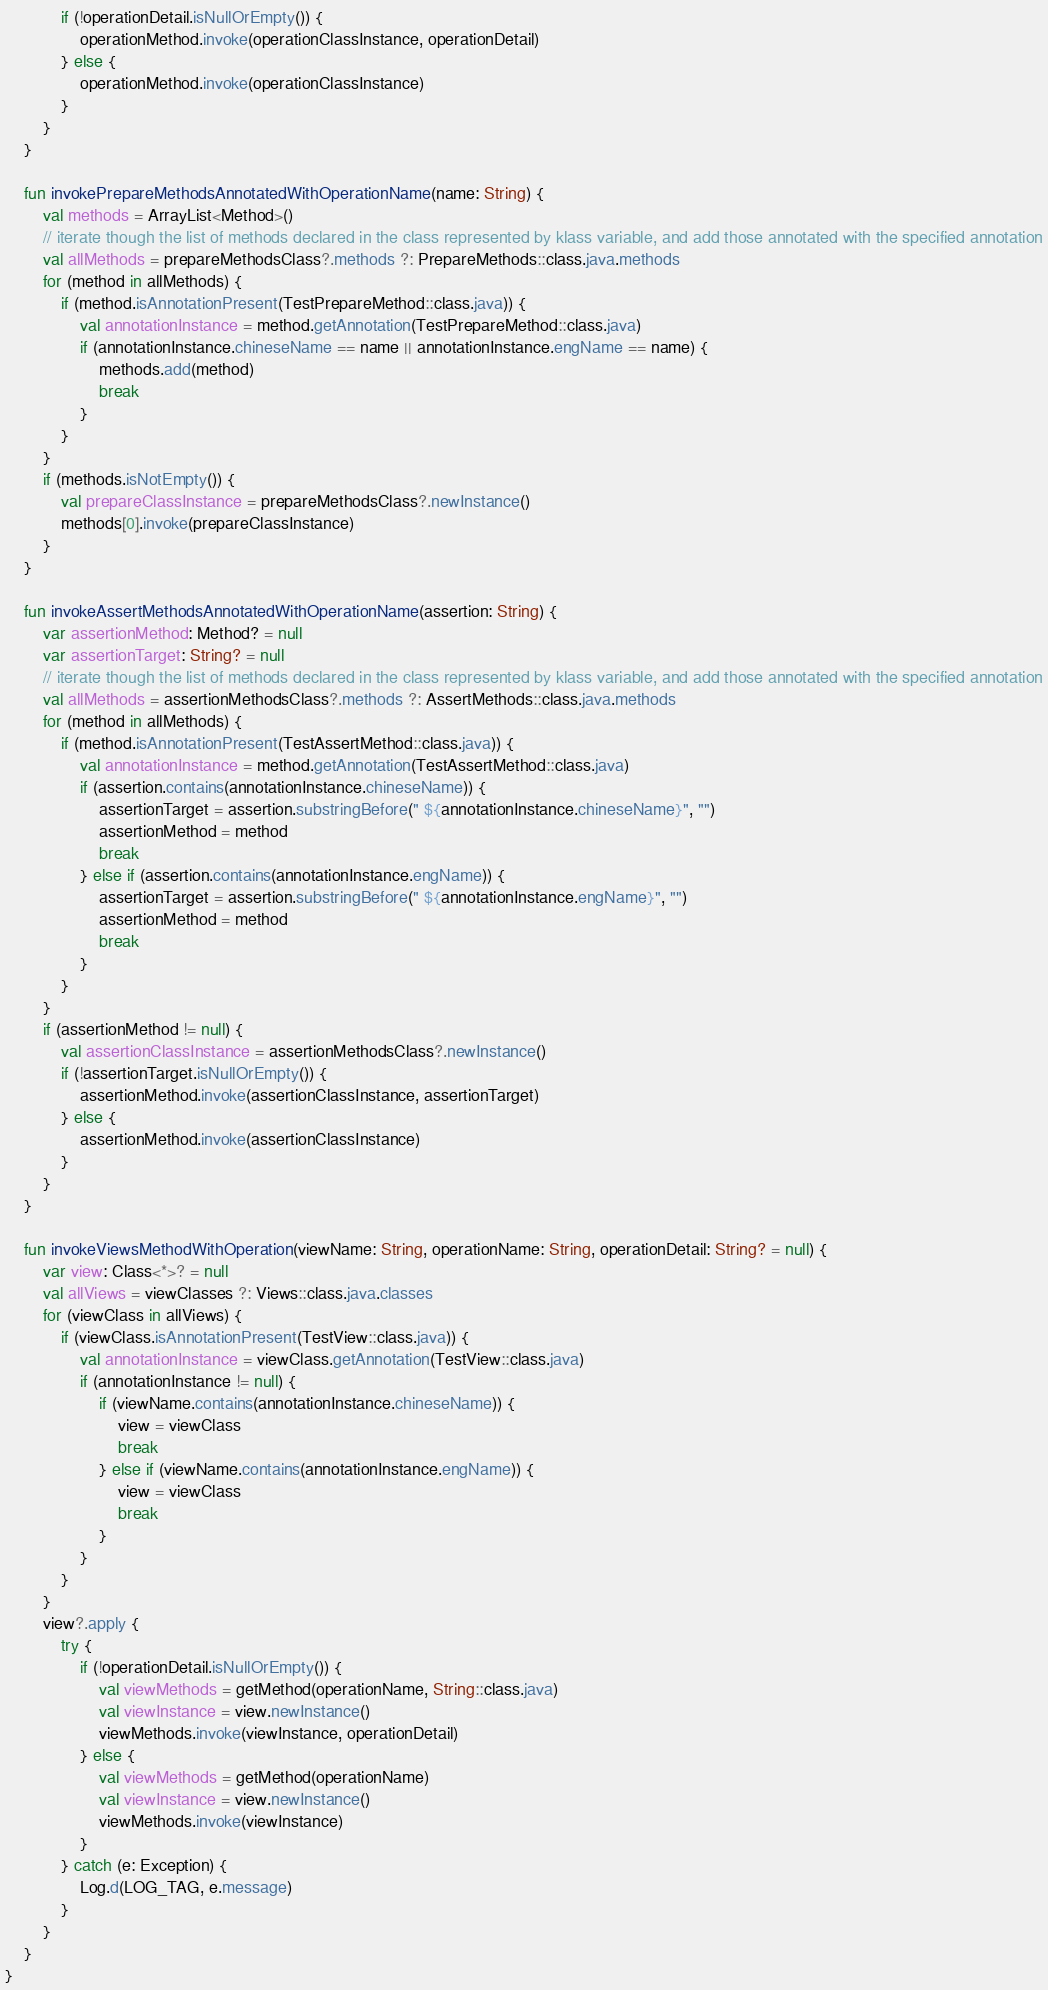Convert code to text. <code><loc_0><loc_0><loc_500><loc_500><_Kotlin_>            if (!operationDetail.isNullOrEmpty()) {
                operationMethod.invoke(operationClassInstance, operationDetail)
            } else {
                operationMethod.invoke(operationClassInstance)
            }
        }
    }

    fun invokePrepareMethodsAnnotatedWithOperationName(name: String) {
        val methods = ArrayList<Method>()
        // iterate though the list of methods declared in the class represented by klass variable, and add those annotated with the specified annotation
        val allMethods = prepareMethodsClass?.methods ?: PrepareMethods::class.java.methods
        for (method in allMethods) {
            if (method.isAnnotationPresent(TestPrepareMethod::class.java)) {
                val annotationInstance = method.getAnnotation(TestPrepareMethod::class.java)
                if (annotationInstance.chineseName == name || annotationInstance.engName == name) {
                    methods.add(method)
                    break
                }
            }
        }
        if (methods.isNotEmpty()) {
            val prepareClassInstance = prepareMethodsClass?.newInstance()
            methods[0].invoke(prepareClassInstance)
        }
    }

    fun invokeAssertMethodsAnnotatedWithOperationName(assertion: String) {
        var assertionMethod: Method? = null
        var assertionTarget: String? = null
        // iterate though the list of methods declared in the class represented by klass variable, and add those annotated with the specified annotation
        val allMethods = assertionMethodsClass?.methods ?: AssertMethods::class.java.methods
        for (method in allMethods) {
            if (method.isAnnotationPresent(TestAssertMethod::class.java)) {
                val annotationInstance = method.getAnnotation(TestAssertMethod::class.java)
                if (assertion.contains(annotationInstance.chineseName)) {
                    assertionTarget = assertion.substringBefore(" ${annotationInstance.chineseName}", "")
                    assertionMethod = method
                    break
                } else if (assertion.contains(annotationInstance.engName)) {
                    assertionTarget = assertion.substringBefore(" ${annotationInstance.engName}", "")
                    assertionMethod = method
                    break
                }
            }
        }
        if (assertionMethod != null) {
            val assertionClassInstance = assertionMethodsClass?.newInstance()
            if (!assertionTarget.isNullOrEmpty()) {
                assertionMethod.invoke(assertionClassInstance, assertionTarget)
            } else {
                assertionMethod.invoke(assertionClassInstance)
            }
        }
    }

    fun invokeViewsMethodWithOperation(viewName: String, operationName: String, operationDetail: String? = null) {
        var view: Class<*>? = null
        val allViews = viewClasses ?: Views::class.java.classes
        for (viewClass in allViews) {
            if (viewClass.isAnnotationPresent(TestView::class.java)) {
                val annotationInstance = viewClass.getAnnotation(TestView::class.java)
                if (annotationInstance != null) {
                    if (viewName.contains(annotationInstance.chineseName)) {
                        view = viewClass
                        break
                    } else if (viewName.contains(annotationInstance.engName)) {
                        view = viewClass
                        break
                    }
                }
            }
        }
        view?.apply {
            try {
                if (!operationDetail.isNullOrEmpty()) {
                    val viewMethods = getMethod(operationName, String::class.java)
                    val viewInstance = view.newInstance()
                    viewMethods.invoke(viewInstance, operationDetail)
                } else {
                    val viewMethods = getMethod(operationName)
                    val viewInstance = view.newInstance()
                    viewMethods.invoke(viewInstance)
                }
            } catch (e: Exception) {
                Log.d(LOG_TAG, e.message)
            }
        }
    }
}</code> 